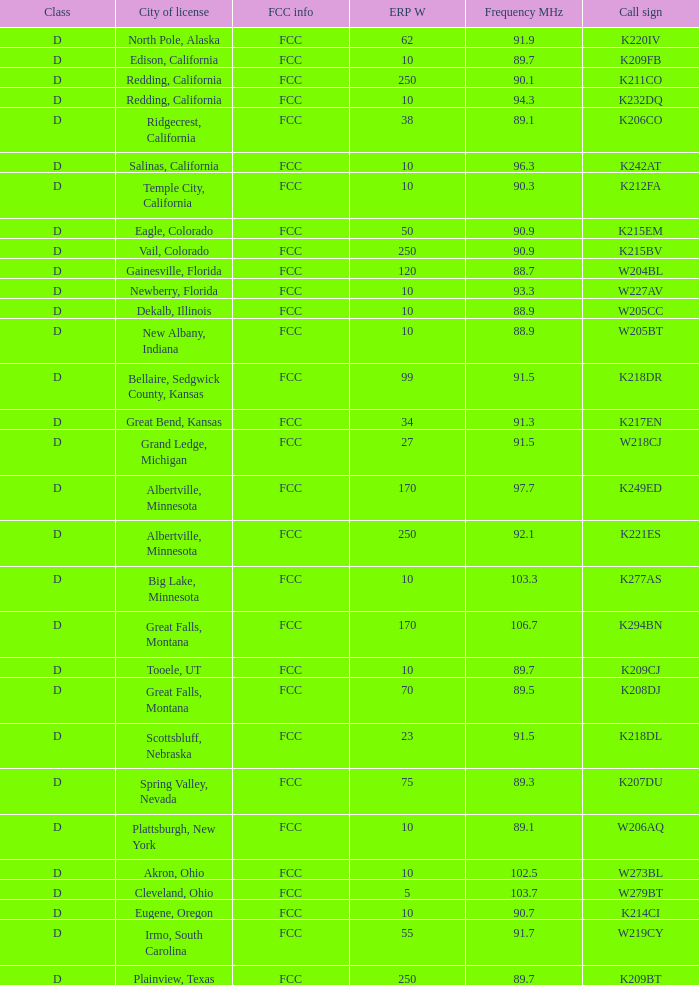Could you parse the entire table as a dict? {'header': ['Class', 'City of license', 'FCC info', 'ERP W', 'Frequency MHz', 'Call sign'], 'rows': [['D', 'North Pole, Alaska', 'FCC', '62', '91.9', 'K220IV'], ['D', 'Edison, California', 'FCC', '10', '89.7', 'K209FB'], ['D', 'Redding, California', 'FCC', '250', '90.1', 'K211CO'], ['D', 'Redding, California', 'FCC', '10', '94.3', 'K232DQ'], ['D', 'Ridgecrest, California', 'FCC', '38', '89.1', 'K206CO'], ['D', 'Salinas, California', 'FCC', '10', '96.3', 'K242AT'], ['D', 'Temple City, California', 'FCC', '10', '90.3', 'K212FA'], ['D', 'Eagle, Colorado', 'FCC', '50', '90.9', 'K215EM'], ['D', 'Vail, Colorado', 'FCC', '250', '90.9', 'K215BV'], ['D', 'Gainesville, Florida', 'FCC', '120', '88.7', 'W204BL'], ['D', 'Newberry, Florida', 'FCC', '10', '93.3', 'W227AV'], ['D', 'Dekalb, Illinois', 'FCC', '10', '88.9', 'W205CC'], ['D', 'New Albany, Indiana', 'FCC', '10', '88.9', 'W205BT'], ['D', 'Bellaire, Sedgwick County, Kansas', 'FCC', '99', '91.5', 'K218DR'], ['D', 'Great Bend, Kansas', 'FCC', '34', '91.3', 'K217EN'], ['D', 'Grand Ledge, Michigan', 'FCC', '27', '91.5', 'W218CJ'], ['D', 'Albertville, Minnesota', 'FCC', '170', '97.7', 'K249ED'], ['D', 'Albertville, Minnesota', 'FCC', '250', '92.1', 'K221ES'], ['D', 'Big Lake, Minnesota', 'FCC', '10', '103.3', 'K277AS'], ['D', 'Great Falls, Montana', 'FCC', '170', '106.7', 'K294BN'], ['D', 'Tooele, UT', 'FCC', '10', '89.7', 'K209CJ'], ['D', 'Great Falls, Montana', 'FCC', '70', '89.5', 'K208DJ'], ['D', 'Scottsbluff, Nebraska', 'FCC', '23', '91.5', 'K218DL'], ['D', 'Spring Valley, Nevada', 'FCC', '75', '89.3', 'K207DU'], ['D', 'Plattsburgh, New York', 'FCC', '10', '89.1', 'W206AQ'], ['D', 'Akron, Ohio', 'FCC', '10', '102.5', 'W273BL'], ['D', 'Cleveland, Ohio', 'FCC', '5', '103.7', 'W279BT'], ['D', 'Eugene, Oregon', 'FCC', '10', '90.7', 'K214CI'], ['D', 'Irmo, South Carolina', 'FCC', '55', '91.7', 'W219CY'], ['D', 'Plainview, Texas', 'FCC', '250', '89.7', 'K209BT']]} What is the highest ERP W of an 89.1 frequency translator? 38.0. 